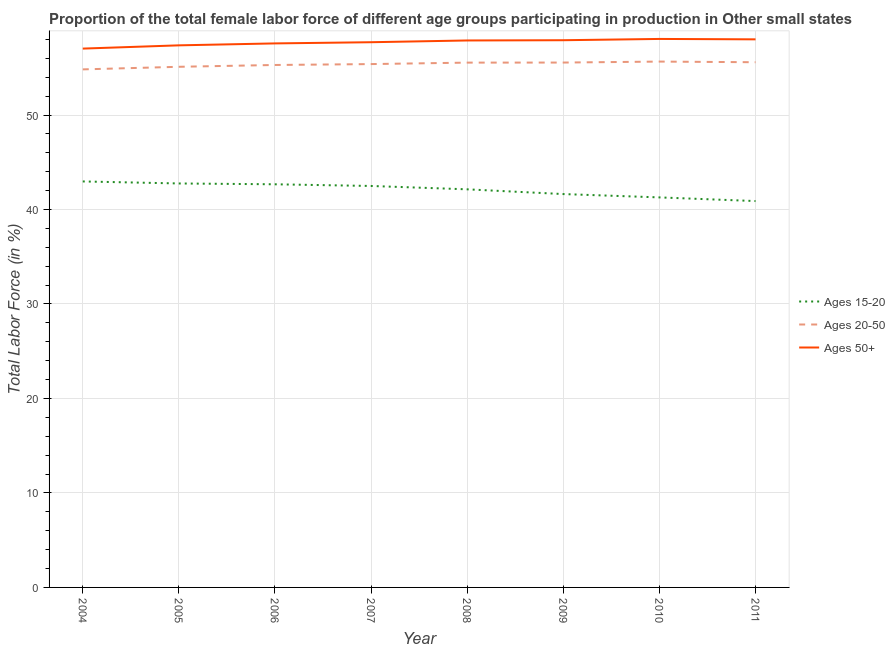How many different coloured lines are there?
Provide a short and direct response. 3. Is the number of lines equal to the number of legend labels?
Offer a very short reply. Yes. What is the percentage of female labor force within the age group 20-50 in 2009?
Your answer should be compact. 55.55. Across all years, what is the maximum percentage of female labor force within the age group 15-20?
Keep it short and to the point. 42.97. Across all years, what is the minimum percentage of female labor force within the age group 20-50?
Your answer should be compact. 54.83. In which year was the percentage of female labor force within the age group 15-20 minimum?
Provide a short and direct response. 2011. What is the total percentage of female labor force within the age group 20-50 in the graph?
Offer a very short reply. 442.95. What is the difference between the percentage of female labor force above age 50 in 2008 and that in 2011?
Offer a terse response. -0.12. What is the difference between the percentage of female labor force within the age group 15-20 in 2007 and the percentage of female labor force within the age group 20-50 in 2005?
Offer a very short reply. -12.61. What is the average percentage of female labor force above age 50 per year?
Your answer should be very brief. 57.69. In the year 2008, what is the difference between the percentage of female labor force within the age group 20-50 and percentage of female labor force within the age group 15-20?
Offer a terse response. 13.41. In how many years, is the percentage of female labor force above age 50 greater than 52 %?
Keep it short and to the point. 8. What is the ratio of the percentage of female labor force above age 50 in 2004 to that in 2008?
Your answer should be compact. 0.99. Is the percentage of female labor force above age 50 in 2009 less than that in 2011?
Ensure brevity in your answer.  Yes. Is the difference between the percentage of female labor force within the age group 15-20 in 2005 and 2008 greater than the difference between the percentage of female labor force within the age group 20-50 in 2005 and 2008?
Offer a very short reply. Yes. What is the difference between the highest and the second highest percentage of female labor force above age 50?
Provide a short and direct response. 0.04. What is the difference between the highest and the lowest percentage of female labor force above age 50?
Ensure brevity in your answer.  1.02. Does the percentage of female labor force within the age group 20-50 monotonically increase over the years?
Offer a terse response. No. How many lines are there?
Provide a succinct answer. 3. How many years are there in the graph?
Provide a succinct answer. 8. What is the difference between two consecutive major ticks on the Y-axis?
Offer a terse response. 10. Where does the legend appear in the graph?
Give a very brief answer. Center right. How are the legend labels stacked?
Your response must be concise. Vertical. What is the title of the graph?
Provide a short and direct response. Proportion of the total female labor force of different age groups participating in production in Other small states. Does "Transport equipments" appear as one of the legend labels in the graph?
Ensure brevity in your answer.  No. What is the Total Labor Force (in %) in Ages 15-20 in 2004?
Give a very brief answer. 42.97. What is the Total Labor Force (in %) in Ages 20-50 in 2004?
Offer a terse response. 54.83. What is the Total Labor Force (in %) of Ages 50+ in 2004?
Provide a short and direct response. 57.03. What is the Total Labor Force (in %) in Ages 15-20 in 2005?
Provide a short and direct response. 42.75. What is the Total Labor Force (in %) in Ages 20-50 in 2005?
Ensure brevity in your answer.  55.1. What is the Total Labor Force (in %) of Ages 50+ in 2005?
Give a very brief answer. 57.37. What is the Total Labor Force (in %) of Ages 15-20 in 2006?
Your answer should be compact. 42.67. What is the Total Labor Force (in %) of Ages 20-50 in 2006?
Give a very brief answer. 55.3. What is the Total Labor Force (in %) of Ages 50+ in 2006?
Offer a terse response. 57.58. What is the Total Labor Force (in %) in Ages 15-20 in 2007?
Your response must be concise. 42.49. What is the Total Labor Force (in %) in Ages 20-50 in 2007?
Offer a terse response. 55.39. What is the Total Labor Force (in %) in Ages 50+ in 2007?
Your answer should be very brief. 57.7. What is the Total Labor Force (in %) in Ages 15-20 in 2008?
Keep it short and to the point. 42.13. What is the Total Labor Force (in %) in Ages 20-50 in 2008?
Keep it short and to the point. 55.54. What is the Total Labor Force (in %) in Ages 50+ in 2008?
Provide a short and direct response. 57.89. What is the Total Labor Force (in %) in Ages 15-20 in 2009?
Make the answer very short. 41.63. What is the Total Labor Force (in %) in Ages 20-50 in 2009?
Your answer should be compact. 55.55. What is the Total Labor Force (in %) in Ages 50+ in 2009?
Your response must be concise. 57.92. What is the Total Labor Force (in %) in Ages 15-20 in 2010?
Provide a short and direct response. 41.28. What is the Total Labor Force (in %) of Ages 20-50 in 2010?
Offer a terse response. 55.65. What is the Total Labor Force (in %) in Ages 50+ in 2010?
Your answer should be very brief. 58.05. What is the Total Labor Force (in %) in Ages 15-20 in 2011?
Your answer should be compact. 40.89. What is the Total Labor Force (in %) of Ages 20-50 in 2011?
Make the answer very short. 55.59. What is the Total Labor Force (in %) in Ages 50+ in 2011?
Provide a short and direct response. 58.01. Across all years, what is the maximum Total Labor Force (in %) in Ages 15-20?
Offer a terse response. 42.97. Across all years, what is the maximum Total Labor Force (in %) of Ages 20-50?
Your answer should be very brief. 55.65. Across all years, what is the maximum Total Labor Force (in %) in Ages 50+?
Give a very brief answer. 58.05. Across all years, what is the minimum Total Labor Force (in %) of Ages 15-20?
Keep it short and to the point. 40.89. Across all years, what is the minimum Total Labor Force (in %) in Ages 20-50?
Give a very brief answer. 54.83. Across all years, what is the minimum Total Labor Force (in %) of Ages 50+?
Offer a very short reply. 57.03. What is the total Total Labor Force (in %) in Ages 15-20 in the graph?
Make the answer very short. 336.82. What is the total Total Labor Force (in %) in Ages 20-50 in the graph?
Your answer should be compact. 442.95. What is the total Total Labor Force (in %) in Ages 50+ in the graph?
Keep it short and to the point. 461.55. What is the difference between the Total Labor Force (in %) in Ages 15-20 in 2004 and that in 2005?
Provide a succinct answer. 0.21. What is the difference between the Total Labor Force (in %) of Ages 20-50 in 2004 and that in 2005?
Your response must be concise. -0.27. What is the difference between the Total Labor Force (in %) in Ages 50+ in 2004 and that in 2005?
Your response must be concise. -0.35. What is the difference between the Total Labor Force (in %) of Ages 15-20 in 2004 and that in 2006?
Give a very brief answer. 0.3. What is the difference between the Total Labor Force (in %) in Ages 20-50 in 2004 and that in 2006?
Your answer should be very brief. -0.47. What is the difference between the Total Labor Force (in %) of Ages 50+ in 2004 and that in 2006?
Ensure brevity in your answer.  -0.55. What is the difference between the Total Labor Force (in %) in Ages 15-20 in 2004 and that in 2007?
Offer a terse response. 0.48. What is the difference between the Total Labor Force (in %) of Ages 20-50 in 2004 and that in 2007?
Keep it short and to the point. -0.56. What is the difference between the Total Labor Force (in %) in Ages 50+ in 2004 and that in 2007?
Give a very brief answer. -0.68. What is the difference between the Total Labor Force (in %) of Ages 15-20 in 2004 and that in 2008?
Your answer should be very brief. 0.84. What is the difference between the Total Labor Force (in %) of Ages 20-50 in 2004 and that in 2008?
Your answer should be compact. -0.72. What is the difference between the Total Labor Force (in %) of Ages 50+ in 2004 and that in 2008?
Keep it short and to the point. -0.86. What is the difference between the Total Labor Force (in %) of Ages 15-20 in 2004 and that in 2009?
Ensure brevity in your answer.  1.34. What is the difference between the Total Labor Force (in %) in Ages 20-50 in 2004 and that in 2009?
Provide a succinct answer. -0.72. What is the difference between the Total Labor Force (in %) of Ages 50+ in 2004 and that in 2009?
Offer a very short reply. -0.89. What is the difference between the Total Labor Force (in %) of Ages 15-20 in 2004 and that in 2010?
Give a very brief answer. 1.69. What is the difference between the Total Labor Force (in %) of Ages 20-50 in 2004 and that in 2010?
Offer a very short reply. -0.83. What is the difference between the Total Labor Force (in %) of Ages 50+ in 2004 and that in 2010?
Give a very brief answer. -1.02. What is the difference between the Total Labor Force (in %) of Ages 15-20 in 2004 and that in 2011?
Offer a very short reply. 2.08. What is the difference between the Total Labor Force (in %) of Ages 20-50 in 2004 and that in 2011?
Keep it short and to the point. -0.76. What is the difference between the Total Labor Force (in %) in Ages 50+ in 2004 and that in 2011?
Your answer should be compact. -0.98. What is the difference between the Total Labor Force (in %) in Ages 15-20 in 2005 and that in 2006?
Your response must be concise. 0.09. What is the difference between the Total Labor Force (in %) in Ages 20-50 in 2005 and that in 2006?
Keep it short and to the point. -0.19. What is the difference between the Total Labor Force (in %) of Ages 50+ in 2005 and that in 2006?
Your answer should be very brief. -0.2. What is the difference between the Total Labor Force (in %) in Ages 15-20 in 2005 and that in 2007?
Your answer should be compact. 0.27. What is the difference between the Total Labor Force (in %) of Ages 20-50 in 2005 and that in 2007?
Make the answer very short. -0.29. What is the difference between the Total Labor Force (in %) of Ages 50+ in 2005 and that in 2007?
Ensure brevity in your answer.  -0.33. What is the difference between the Total Labor Force (in %) of Ages 15-20 in 2005 and that in 2008?
Make the answer very short. 0.62. What is the difference between the Total Labor Force (in %) of Ages 20-50 in 2005 and that in 2008?
Ensure brevity in your answer.  -0.44. What is the difference between the Total Labor Force (in %) of Ages 50+ in 2005 and that in 2008?
Offer a terse response. -0.52. What is the difference between the Total Labor Force (in %) in Ages 15-20 in 2005 and that in 2009?
Keep it short and to the point. 1.12. What is the difference between the Total Labor Force (in %) in Ages 20-50 in 2005 and that in 2009?
Keep it short and to the point. -0.45. What is the difference between the Total Labor Force (in %) of Ages 50+ in 2005 and that in 2009?
Your answer should be compact. -0.54. What is the difference between the Total Labor Force (in %) in Ages 15-20 in 2005 and that in 2010?
Provide a succinct answer. 1.48. What is the difference between the Total Labor Force (in %) in Ages 20-50 in 2005 and that in 2010?
Ensure brevity in your answer.  -0.55. What is the difference between the Total Labor Force (in %) in Ages 50+ in 2005 and that in 2010?
Make the answer very short. -0.68. What is the difference between the Total Labor Force (in %) of Ages 15-20 in 2005 and that in 2011?
Your response must be concise. 1.86. What is the difference between the Total Labor Force (in %) of Ages 20-50 in 2005 and that in 2011?
Provide a succinct answer. -0.48. What is the difference between the Total Labor Force (in %) of Ages 50+ in 2005 and that in 2011?
Your answer should be compact. -0.63. What is the difference between the Total Labor Force (in %) in Ages 15-20 in 2006 and that in 2007?
Give a very brief answer. 0.18. What is the difference between the Total Labor Force (in %) in Ages 20-50 in 2006 and that in 2007?
Your answer should be compact. -0.09. What is the difference between the Total Labor Force (in %) of Ages 50+ in 2006 and that in 2007?
Offer a very short reply. -0.13. What is the difference between the Total Labor Force (in %) of Ages 15-20 in 2006 and that in 2008?
Offer a very short reply. 0.53. What is the difference between the Total Labor Force (in %) in Ages 20-50 in 2006 and that in 2008?
Offer a terse response. -0.25. What is the difference between the Total Labor Force (in %) of Ages 50+ in 2006 and that in 2008?
Provide a short and direct response. -0.31. What is the difference between the Total Labor Force (in %) in Ages 15-20 in 2006 and that in 2009?
Your answer should be compact. 1.03. What is the difference between the Total Labor Force (in %) of Ages 20-50 in 2006 and that in 2009?
Your response must be concise. -0.26. What is the difference between the Total Labor Force (in %) in Ages 50+ in 2006 and that in 2009?
Your answer should be very brief. -0.34. What is the difference between the Total Labor Force (in %) of Ages 15-20 in 2006 and that in 2010?
Your answer should be very brief. 1.39. What is the difference between the Total Labor Force (in %) of Ages 20-50 in 2006 and that in 2010?
Your response must be concise. -0.36. What is the difference between the Total Labor Force (in %) in Ages 50+ in 2006 and that in 2010?
Your response must be concise. -0.47. What is the difference between the Total Labor Force (in %) of Ages 15-20 in 2006 and that in 2011?
Your answer should be very brief. 1.78. What is the difference between the Total Labor Force (in %) in Ages 20-50 in 2006 and that in 2011?
Provide a succinct answer. -0.29. What is the difference between the Total Labor Force (in %) in Ages 50+ in 2006 and that in 2011?
Your answer should be very brief. -0.43. What is the difference between the Total Labor Force (in %) in Ages 15-20 in 2007 and that in 2008?
Offer a terse response. 0.35. What is the difference between the Total Labor Force (in %) of Ages 20-50 in 2007 and that in 2008?
Ensure brevity in your answer.  -0.15. What is the difference between the Total Labor Force (in %) in Ages 50+ in 2007 and that in 2008?
Give a very brief answer. -0.18. What is the difference between the Total Labor Force (in %) in Ages 15-20 in 2007 and that in 2009?
Your response must be concise. 0.86. What is the difference between the Total Labor Force (in %) in Ages 20-50 in 2007 and that in 2009?
Provide a succinct answer. -0.16. What is the difference between the Total Labor Force (in %) of Ages 50+ in 2007 and that in 2009?
Make the answer very short. -0.21. What is the difference between the Total Labor Force (in %) of Ages 15-20 in 2007 and that in 2010?
Offer a terse response. 1.21. What is the difference between the Total Labor Force (in %) in Ages 20-50 in 2007 and that in 2010?
Provide a succinct answer. -0.26. What is the difference between the Total Labor Force (in %) in Ages 50+ in 2007 and that in 2010?
Ensure brevity in your answer.  -0.35. What is the difference between the Total Labor Force (in %) in Ages 15-20 in 2007 and that in 2011?
Your answer should be very brief. 1.6. What is the difference between the Total Labor Force (in %) in Ages 20-50 in 2007 and that in 2011?
Provide a succinct answer. -0.2. What is the difference between the Total Labor Force (in %) of Ages 50+ in 2007 and that in 2011?
Offer a terse response. -0.3. What is the difference between the Total Labor Force (in %) in Ages 15-20 in 2008 and that in 2009?
Your answer should be very brief. 0.5. What is the difference between the Total Labor Force (in %) of Ages 20-50 in 2008 and that in 2009?
Offer a terse response. -0.01. What is the difference between the Total Labor Force (in %) of Ages 50+ in 2008 and that in 2009?
Give a very brief answer. -0.03. What is the difference between the Total Labor Force (in %) in Ages 15-20 in 2008 and that in 2010?
Your answer should be compact. 0.85. What is the difference between the Total Labor Force (in %) in Ages 20-50 in 2008 and that in 2010?
Your response must be concise. -0.11. What is the difference between the Total Labor Force (in %) in Ages 50+ in 2008 and that in 2010?
Provide a succinct answer. -0.16. What is the difference between the Total Labor Force (in %) of Ages 15-20 in 2008 and that in 2011?
Provide a short and direct response. 1.24. What is the difference between the Total Labor Force (in %) of Ages 20-50 in 2008 and that in 2011?
Provide a short and direct response. -0.04. What is the difference between the Total Labor Force (in %) in Ages 50+ in 2008 and that in 2011?
Offer a very short reply. -0.12. What is the difference between the Total Labor Force (in %) in Ages 15-20 in 2009 and that in 2010?
Keep it short and to the point. 0.35. What is the difference between the Total Labor Force (in %) in Ages 20-50 in 2009 and that in 2010?
Give a very brief answer. -0.1. What is the difference between the Total Labor Force (in %) of Ages 50+ in 2009 and that in 2010?
Ensure brevity in your answer.  -0.14. What is the difference between the Total Labor Force (in %) of Ages 15-20 in 2009 and that in 2011?
Your response must be concise. 0.74. What is the difference between the Total Labor Force (in %) of Ages 20-50 in 2009 and that in 2011?
Provide a succinct answer. -0.03. What is the difference between the Total Labor Force (in %) of Ages 50+ in 2009 and that in 2011?
Provide a short and direct response. -0.09. What is the difference between the Total Labor Force (in %) in Ages 15-20 in 2010 and that in 2011?
Give a very brief answer. 0.39. What is the difference between the Total Labor Force (in %) of Ages 20-50 in 2010 and that in 2011?
Your answer should be compact. 0.07. What is the difference between the Total Labor Force (in %) in Ages 50+ in 2010 and that in 2011?
Provide a succinct answer. 0.04. What is the difference between the Total Labor Force (in %) of Ages 15-20 in 2004 and the Total Labor Force (in %) of Ages 20-50 in 2005?
Your answer should be compact. -12.13. What is the difference between the Total Labor Force (in %) of Ages 15-20 in 2004 and the Total Labor Force (in %) of Ages 50+ in 2005?
Your answer should be very brief. -14.4. What is the difference between the Total Labor Force (in %) in Ages 20-50 in 2004 and the Total Labor Force (in %) in Ages 50+ in 2005?
Your answer should be compact. -2.54. What is the difference between the Total Labor Force (in %) in Ages 15-20 in 2004 and the Total Labor Force (in %) in Ages 20-50 in 2006?
Give a very brief answer. -12.33. What is the difference between the Total Labor Force (in %) of Ages 15-20 in 2004 and the Total Labor Force (in %) of Ages 50+ in 2006?
Provide a short and direct response. -14.61. What is the difference between the Total Labor Force (in %) of Ages 20-50 in 2004 and the Total Labor Force (in %) of Ages 50+ in 2006?
Offer a very short reply. -2.75. What is the difference between the Total Labor Force (in %) of Ages 15-20 in 2004 and the Total Labor Force (in %) of Ages 20-50 in 2007?
Ensure brevity in your answer.  -12.42. What is the difference between the Total Labor Force (in %) in Ages 15-20 in 2004 and the Total Labor Force (in %) in Ages 50+ in 2007?
Your answer should be compact. -14.74. What is the difference between the Total Labor Force (in %) in Ages 20-50 in 2004 and the Total Labor Force (in %) in Ages 50+ in 2007?
Provide a succinct answer. -2.88. What is the difference between the Total Labor Force (in %) in Ages 15-20 in 2004 and the Total Labor Force (in %) in Ages 20-50 in 2008?
Provide a succinct answer. -12.58. What is the difference between the Total Labor Force (in %) of Ages 15-20 in 2004 and the Total Labor Force (in %) of Ages 50+ in 2008?
Provide a short and direct response. -14.92. What is the difference between the Total Labor Force (in %) of Ages 20-50 in 2004 and the Total Labor Force (in %) of Ages 50+ in 2008?
Provide a short and direct response. -3.06. What is the difference between the Total Labor Force (in %) of Ages 15-20 in 2004 and the Total Labor Force (in %) of Ages 20-50 in 2009?
Keep it short and to the point. -12.58. What is the difference between the Total Labor Force (in %) in Ages 15-20 in 2004 and the Total Labor Force (in %) in Ages 50+ in 2009?
Ensure brevity in your answer.  -14.95. What is the difference between the Total Labor Force (in %) in Ages 20-50 in 2004 and the Total Labor Force (in %) in Ages 50+ in 2009?
Give a very brief answer. -3.09. What is the difference between the Total Labor Force (in %) of Ages 15-20 in 2004 and the Total Labor Force (in %) of Ages 20-50 in 2010?
Provide a short and direct response. -12.69. What is the difference between the Total Labor Force (in %) of Ages 15-20 in 2004 and the Total Labor Force (in %) of Ages 50+ in 2010?
Your response must be concise. -15.08. What is the difference between the Total Labor Force (in %) of Ages 20-50 in 2004 and the Total Labor Force (in %) of Ages 50+ in 2010?
Your answer should be very brief. -3.22. What is the difference between the Total Labor Force (in %) of Ages 15-20 in 2004 and the Total Labor Force (in %) of Ages 20-50 in 2011?
Make the answer very short. -12.62. What is the difference between the Total Labor Force (in %) of Ages 15-20 in 2004 and the Total Labor Force (in %) of Ages 50+ in 2011?
Provide a short and direct response. -15.04. What is the difference between the Total Labor Force (in %) in Ages 20-50 in 2004 and the Total Labor Force (in %) in Ages 50+ in 2011?
Provide a short and direct response. -3.18. What is the difference between the Total Labor Force (in %) of Ages 15-20 in 2005 and the Total Labor Force (in %) of Ages 20-50 in 2006?
Keep it short and to the point. -12.54. What is the difference between the Total Labor Force (in %) of Ages 15-20 in 2005 and the Total Labor Force (in %) of Ages 50+ in 2006?
Your response must be concise. -14.82. What is the difference between the Total Labor Force (in %) in Ages 20-50 in 2005 and the Total Labor Force (in %) in Ages 50+ in 2006?
Provide a short and direct response. -2.48. What is the difference between the Total Labor Force (in %) in Ages 15-20 in 2005 and the Total Labor Force (in %) in Ages 20-50 in 2007?
Make the answer very short. -12.64. What is the difference between the Total Labor Force (in %) in Ages 15-20 in 2005 and the Total Labor Force (in %) in Ages 50+ in 2007?
Ensure brevity in your answer.  -14.95. What is the difference between the Total Labor Force (in %) of Ages 20-50 in 2005 and the Total Labor Force (in %) of Ages 50+ in 2007?
Offer a very short reply. -2.6. What is the difference between the Total Labor Force (in %) of Ages 15-20 in 2005 and the Total Labor Force (in %) of Ages 20-50 in 2008?
Your answer should be compact. -12.79. What is the difference between the Total Labor Force (in %) in Ages 15-20 in 2005 and the Total Labor Force (in %) in Ages 50+ in 2008?
Make the answer very short. -15.13. What is the difference between the Total Labor Force (in %) in Ages 20-50 in 2005 and the Total Labor Force (in %) in Ages 50+ in 2008?
Provide a short and direct response. -2.79. What is the difference between the Total Labor Force (in %) in Ages 15-20 in 2005 and the Total Labor Force (in %) in Ages 20-50 in 2009?
Your response must be concise. -12.8. What is the difference between the Total Labor Force (in %) of Ages 15-20 in 2005 and the Total Labor Force (in %) of Ages 50+ in 2009?
Your response must be concise. -15.16. What is the difference between the Total Labor Force (in %) in Ages 20-50 in 2005 and the Total Labor Force (in %) in Ages 50+ in 2009?
Provide a succinct answer. -2.81. What is the difference between the Total Labor Force (in %) of Ages 15-20 in 2005 and the Total Labor Force (in %) of Ages 20-50 in 2010?
Give a very brief answer. -12.9. What is the difference between the Total Labor Force (in %) in Ages 15-20 in 2005 and the Total Labor Force (in %) in Ages 50+ in 2010?
Offer a terse response. -15.3. What is the difference between the Total Labor Force (in %) in Ages 20-50 in 2005 and the Total Labor Force (in %) in Ages 50+ in 2010?
Give a very brief answer. -2.95. What is the difference between the Total Labor Force (in %) in Ages 15-20 in 2005 and the Total Labor Force (in %) in Ages 20-50 in 2011?
Your answer should be compact. -12.83. What is the difference between the Total Labor Force (in %) in Ages 15-20 in 2005 and the Total Labor Force (in %) in Ages 50+ in 2011?
Ensure brevity in your answer.  -15.25. What is the difference between the Total Labor Force (in %) in Ages 20-50 in 2005 and the Total Labor Force (in %) in Ages 50+ in 2011?
Your response must be concise. -2.91. What is the difference between the Total Labor Force (in %) in Ages 15-20 in 2006 and the Total Labor Force (in %) in Ages 20-50 in 2007?
Ensure brevity in your answer.  -12.72. What is the difference between the Total Labor Force (in %) of Ages 15-20 in 2006 and the Total Labor Force (in %) of Ages 50+ in 2007?
Provide a succinct answer. -15.04. What is the difference between the Total Labor Force (in %) of Ages 20-50 in 2006 and the Total Labor Force (in %) of Ages 50+ in 2007?
Provide a short and direct response. -2.41. What is the difference between the Total Labor Force (in %) of Ages 15-20 in 2006 and the Total Labor Force (in %) of Ages 20-50 in 2008?
Give a very brief answer. -12.88. What is the difference between the Total Labor Force (in %) in Ages 15-20 in 2006 and the Total Labor Force (in %) in Ages 50+ in 2008?
Provide a succinct answer. -15.22. What is the difference between the Total Labor Force (in %) of Ages 20-50 in 2006 and the Total Labor Force (in %) of Ages 50+ in 2008?
Give a very brief answer. -2.59. What is the difference between the Total Labor Force (in %) in Ages 15-20 in 2006 and the Total Labor Force (in %) in Ages 20-50 in 2009?
Provide a succinct answer. -12.88. What is the difference between the Total Labor Force (in %) of Ages 15-20 in 2006 and the Total Labor Force (in %) of Ages 50+ in 2009?
Provide a succinct answer. -15.25. What is the difference between the Total Labor Force (in %) in Ages 20-50 in 2006 and the Total Labor Force (in %) in Ages 50+ in 2009?
Your answer should be compact. -2.62. What is the difference between the Total Labor Force (in %) in Ages 15-20 in 2006 and the Total Labor Force (in %) in Ages 20-50 in 2010?
Provide a succinct answer. -12.99. What is the difference between the Total Labor Force (in %) in Ages 15-20 in 2006 and the Total Labor Force (in %) in Ages 50+ in 2010?
Offer a very short reply. -15.38. What is the difference between the Total Labor Force (in %) in Ages 20-50 in 2006 and the Total Labor Force (in %) in Ages 50+ in 2010?
Ensure brevity in your answer.  -2.76. What is the difference between the Total Labor Force (in %) in Ages 15-20 in 2006 and the Total Labor Force (in %) in Ages 20-50 in 2011?
Ensure brevity in your answer.  -12.92. What is the difference between the Total Labor Force (in %) of Ages 15-20 in 2006 and the Total Labor Force (in %) of Ages 50+ in 2011?
Offer a very short reply. -15.34. What is the difference between the Total Labor Force (in %) in Ages 20-50 in 2006 and the Total Labor Force (in %) in Ages 50+ in 2011?
Provide a short and direct response. -2.71. What is the difference between the Total Labor Force (in %) in Ages 15-20 in 2007 and the Total Labor Force (in %) in Ages 20-50 in 2008?
Ensure brevity in your answer.  -13.06. What is the difference between the Total Labor Force (in %) of Ages 15-20 in 2007 and the Total Labor Force (in %) of Ages 50+ in 2008?
Offer a terse response. -15.4. What is the difference between the Total Labor Force (in %) of Ages 20-50 in 2007 and the Total Labor Force (in %) of Ages 50+ in 2008?
Provide a short and direct response. -2.5. What is the difference between the Total Labor Force (in %) of Ages 15-20 in 2007 and the Total Labor Force (in %) of Ages 20-50 in 2009?
Your answer should be very brief. -13.06. What is the difference between the Total Labor Force (in %) in Ages 15-20 in 2007 and the Total Labor Force (in %) in Ages 50+ in 2009?
Provide a short and direct response. -15.43. What is the difference between the Total Labor Force (in %) of Ages 20-50 in 2007 and the Total Labor Force (in %) of Ages 50+ in 2009?
Give a very brief answer. -2.53. What is the difference between the Total Labor Force (in %) in Ages 15-20 in 2007 and the Total Labor Force (in %) in Ages 20-50 in 2010?
Keep it short and to the point. -13.17. What is the difference between the Total Labor Force (in %) of Ages 15-20 in 2007 and the Total Labor Force (in %) of Ages 50+ in 2010?
Provide a succinct answer. -15.56. What is the difference between the Total Labor Force (in %) in Ages 20-50 in 2007 and the Total Labor Force (in %) in Ages 50+ in 2010?
Offer a terse response. -2.66. What is the difference between the Total Labor Force (in %) in Ages 15-20 in 2007 and the Total Labor Force (in %) in Ages 20-50 in 2011?
Offer a terse response. -13.1. What is the difference between the Total Labor Force (in %) of Ages 15-20 in 2007 and the Total Labor Force (in %) of Ages 50+ in 2011?
Provide a succinct answer. -15.52. What is the difference between the Total Labor Force (in %) in Ages 20-50 in 2007 and the Total Labor Force (in %) in Ages 50+ in 2011?
Provide a succinct answer. -2.62. What is the difference between the Total Labor Force (in %) in Ages 15-20 in 2008 and the Total Labor Force (in %) in Ages 20-50 in 2009?
Provide a succinct answer. -13.42. What is the difference between the Total Labor Force (in %) of Ages 15-20 in 2008 and the Total Labor Force (in %) of Ages 50+ in 2009?
Give a very brief answer. -15.78. What is the difference between the Total Labor Force (in %) of Ages 20-50 in 2008 and the Total Labor Force (in %) of Ages 50+ in 2009?
Keep it short and to the point. -2.37. What is the difference between the Total Labor Force (in %) of Ages 15-20 in 2008 and the Total Labor Force (in %) of Ages 20-50 in 2010?
Offer a very short reply. -13.52. What is the difference between the Total Labor Force (in %) in Ages 15-20 in 2008 and the Total Labor Force (in %) in Ages 50+ in 2010?
Offer a very short reply. -15.92. What is the difference between the Total Labor Force (in %) in Ages 20-50 in 2008 and the Total Labor Force (in %) in Ages 50+ in 2010?
Offer a terse response. -2.51. What is the difference between the Total Labor Force (in %) in Ages 15-20 in 2008 and the Total Labor Force (in %) in Ages 20-50 in 2011?
Your response must be concise. -13.45. What is the difference between the Total Labor Force (in %) in Ages 15-20 in 2008 and the Total Labor Force (in %) in Ages 50+ in 2011?
Provide a succinct answer. -15.87. What is the difference between the Total Labor Force (in %) of Ages 20-50 in 2008 and the Total Labor Force (in %) of Ages 50+ in 2011?
Make the answer very short. -2.46. What is the difference between the Total Labor Force (in %) of Ages 15-20 in 2009 and the Total Labor Force (in %) of Ages 20-50 in 2010?
Provide a succinct answer. -14.02. What is the difference between the Total Labor Force (in %) of Ages 15-20 in 2009 and the Total Labor Force (in %) of Ages 50+ in 2010?
Offer a very short reply. -16.42. What is the difference between the Total Labor Force (in %) in Ages 15-20 in 2009 and the Total Labor Force (in %) in Ages 20-50 in 2011?
Provide a succinct answer. -13.95. What is the difference between the Total Labor Force (in %) of Ages 15-20 in 2009 and the Total Labor Force (in %) of Ages 50+ in 2011?
Provide a succinct answer. -16.38. What is the difference between the Total Labor Force (in %) in Ages 20-50 in 2009 and the Total Labor Force (in %) in Ages 50+ in 2011?
Provide a short and direct response. -2.46. What is the difference between the Total Labor Force (in %) in Ages 15-20 in 2010 and the Total Labor Force (in %) in Ages 20-50 in 2011?
Your answer should be very brief. -14.31. What is the difference between the Total Labor Force (in %) in Ages 15-20 in 2010 and the Total Labor Force (in %) in Ages 50+ in 2011?
Your answer should be very brief. -16.73. What is the difference between the Total Labor Force (in %) of Ages 20-50 in 2010 and the Total Labor Force (in %) of Ages 50+ in 2011?
Provide a short and direct response. -2.35. What is the average Total Labor Force (in %) of Ages 15-20 per year?
Offer a terse response. 42.1. What is the average Total Labor Force (in %) in Ages 20-50 per year?
Make the answer very short. 55.37. What is the average Total Labor Force (in %) of Ages 50+ per year?
Provide a short and direct response. 57.69. In the year 2004, what is the difference between the Total Labor Force (in %) in Ages 15-20 and Total Labor Force (in %) in Ages 20-50?
Provide a short and direct response. -11.86. In the year 2004, what is the difference between the Total Labor Force (in %) in Ages 15-20 and Total Labor Force (in %) in Ages 50+?
Keep it short and to the point. -14.06. In the year 2004, what is the difference between the Total Labor Force (in %) of Ages 20-50 and Total Labor Force (in %) of Ages 50+?
Your response must be concise. -2.2. In the year 2005, what is the difference between the Total Labor Force (in %) in Ages 15-20 and Total Labor Force (in %) in Ages 20-50?
Ensure brevity in your answer.  -12.35. In the year 2005, what is the difference between the Total Labor Force (in %) of Ages 15-20 and Total Labor Force (in %) of Ages 50+?
Ensure brevity in your answer.  -14.62. In the year 2005, what is the difference between the Total Labor Force (in %) of Ages 20-50 and Total Labor Force (in %) of Ages 50+?
Provide a succinct answer. -2.27. In the year 2006, what is the difference between the Total Labor Force (in %) in Ages 15-20 and Total Labor Force (in %) in Ages 20-50?
Give a very brief answer. -12.63. In the year 2006, what is the difference between the Total Labor Force (in %) of Ages 15-20 and Total Labor Force (in %) of Ages 50+?
Provide a short and direct response. -14.91. In the year 2006, what is the difference between the Total Labor Force (in %) in Ages 20-50 and Total Labor Force (in %) in Ages 50+?
Offer a terse response. -2.28. In the year 2007, what is the difference between the Total Labor Force (in %) of Ages 15-20 and Total Labor Force (in %) of Ages 20-50?
Provide a short and direct response. -12.9. In the year 2007, what is the difference between the Total Labor Force (in %) of Ages 15-20 and Total Labor Force (in %) of Ages 50+?
Your response must be concise. -15.22. In the year 2007, what is the difference between the Total Labor Force (in %) of Ages 20-50 and Total Labor Force (in %) of Ages 50+?
Make the answer very short. -2.31. In the year 2008, what is the difference between the Total Labor Force (in %) of Ages 15-20 and Total Labor Force (in %) of Ages 20-50?
Provide a short and direct response. -13.41. In the year 2008, what is the difference between the Total Labor Force (in %) in Ages 15-20 and Total Labor Force (in %) in Ages 50+?
Make the answer very short. -15.75. In the year 2008, what is the difference between the Total Labor Force (in %) in Ages 20-50 and Total Labor Force (in %) in Ages 50+?
Your answer should be very brief. -2.34. In the year 2009, what is the difference between the Total Labor Force (in %) of Ages 15-20 and Total Labor Force (in %) of Ages 20-50?
Your answer should be compact. -13.92. In the year 2009, what is the difference between the Total Labor Force (in %) in Ages 15-20 and Total Labor Force (in %) in Ages 50+?
Your answer should be compact. -16.28. In the year 2009, what is the difference between the Total Labor Force (in %) in Ages 20-50 and Total Labor Force (in %) in Ages 50+?
Your response must be concise. -2.36. In the year 2010, what is the difference between the Total Labor Force (in %) of Ages 15-20 and Total Labor Force (in %) of Ages 20-50?
Make the answer very short. -14.38. In the year 2010, what is the difference between the Total Labor Force (in %) of Ages 15-20 and Total Labor Force (in %) of Ages 50+?
Offer a very short reply. -16.77. In the year 2010, what is the difference between the Total Labor Force (in %) of Ages 20-50 and Total Labor Force (in %) of Ages 50+?
Your answer should be very brief. -2.4. In the year 2011, what is the difference between the Total Labor Force (in %) of Ages 15-20 and Total Labor Force (in %) of Ages 20-50?
Give a very brief answer. -14.69. In the year 2011, what is the difference between the Total Labor Force (in %) of Ages 15-20 and Total Labor Force (in %) of Ages 50+?
Keep it short and to the point. -17.12. In the year 2011, what is the difference between the Total Labor Force (in %) in Ages 20-50 and Total Labor Force (in %) in Ages 50+?
Ensure brevity in your answer.  -2.42. What is the ratio of the Total Labor Force (in %) in Ages 15-20 in 2004 to that in 2005?
Offer a very short reply. 1. What is the ratio of the Total Labor Force (in %) in Ages 20-50 in 2004 to that in 2005?
Your answer should be very brief. 0.99. What is the ratio of the Total Labor Force (in %) of Ages 15-20 in 2004 to that in 2006?
Your answer should be very brief. 1.01. What is the ratio of the Total Labor Force (in %) of Ages 20-50 in 2004 to that in 2006?
Give a very brief answer. 0.99. What is the ratio of the Total Labor Force (in %) of Ages 50+ in 2004 to that in 2006?
Offer a very short reply. 0.99. What is the ratio of the Total Labor Force (in %) of Ages 15-20 in 2004 to that in 2007?
Keep it short and to the point. 1.01. What is the ratio of the Total Labor Force (in %) of Ages 20-50 in 2004 to that in 2007?
Make the answer very short. 0.99. What is the ratio of the Total Labor Force (in %) of Ages 50+ in 2004 to that in 2007?
Your answer should be very brief. 0.99. What is the ratio of the Total Labor Force (in %) in Ages 15-20 in 2004 to that in 2008?
Provide a short and direct response. 1.02. What is the ratio of the Total Labor Force (in %) in Ages 20-50 in 2004 to that in 2008?
Your response must be concise. 0.99. What is the ratio of the Total Labor Force (in %) in Ages 50+ in 2004 to that in 2008?
Keep it short and to the point. 0.99. What is the ratio of the Total Labor Force (in %) of Ages 15-20 in 2004 to that in 2009?
Provide a succinct answer. 1.03. What is the ratio of the Total Labor Force (in %) of Ages 20-50 in 2004 to that in 2009?
Give a very brief answer. 0.99. What is the ratio of the Total Labor Force (in %) of Ages 50+ in 2004 to that in 2009?
Make the answer very short. 0.98. What is the ratio of the Total Labor Force (in %) in Ages 15-20 in 2004 to that in 2010?
Your response must be concise. 1.04. What is the ratio of the Total Labor Force (in %) in Ages 20-50 in 2004 to that in 2010?
Ensure brevity in your answer.  0.99. What is the ratio of the Total Labor Force (in %) of Ages 50+ in 2004 to that in 2010?
Keep it short and to the point. 0.98. What is the ratio of the Total Labor Force (in %) in Ages 15-20 in 2004 to that in 2011?
Offer a very short reply. 1.05. What is the ratio of the Total Labor Force (in %) in Ages 20-50 in 2004 to that in 2011?
Provide a succinct answer. 0.99. What is the ratio of the Total Labor Force (in %) in Ages 50+ in 2004 to that in 2011?
Ensure brevity in your answer.  0.98. What is the ratio of the Total Labor Force (in %) in Ages 20-50 in 2005 to that in 2006?
Offer a terse response. 1. What is the ratio of the Total Labor Force (in %) in Ages 15-20 in 2005 to that in 2008?
Give a very brief answer. 1.01. What is the ratio of the Total Labor Force (in %) of Ages 15-20 in 2005 to that in 2009?
Your answer should be very brief. 1.03. What is the ratio of the Total Labor Force (in %) of Ages 50+ in 2005 to that in 2009?
Your answer should be compact. 0.99. What is the ratio of the Total Labor Force (in %) of Ages 15-20 in 2005 to that in 2010?
Give a very brief answer. 1.04. What is the ratio of the Total Labor Force (in %) of Ages 20-50 in 2005 to that in 2010?
Your answer should be very brief. 0.99. What is the ratio of the Total Labor Force (in %) in Ages 50+ in 2005 to that in 2010?
Provide a short and direct response. 0.99. What is the ratio of the Total Labor Force (in %) of Ages 15-20 in 2005 to that in 2011?
Ensure brevity in your answer.  1.05. What is the ratio of the Total Labor Force (in %) of Ages 50+ in 2005 to that in 2011?
Make the answer very short. 0.99. What is the ratio of the Total Labor Force (in %) of Ages 15-20 in 2006 to that in 2007?
Offer a very short reply. 1. What is the ratio of the Total Labor Force (in %) in Ages 20-50 in 2006 to that in 2007?
Give a very brief answer. 1. What is the ratio of the Total Labor Force (in %) of Ages 15-20 in 2006 to that in 2008?
Ensure brevity in your answer.  1.01. What is the ratio of the Total Labor Force (in %) in Ages 20-50 in 2006 to that in 2008?
Ensure brevity in your answer.  1. What is the ratio of the Total Labor Force (in %) in Ages 50+ in 2006 to that in 2008?
Provide a short and direct response. 0.99. What is the ratio of the Total Labor Force (in %) of Ages 15-20 in 2006 to that in 2009?
Offer a very short reply. 1.02. What is the ratio of the Total Labor Force (in %) in Ages 15-20 in 2006 to that in 2010?
Give a very brief answer. 1.03. What is the ratio of the Total Labor Force (in %) in Ages 15-20 in 2006 to that in 2011?
Offer a very short reply. 1.04. What is the ratio of the Total Labor Force (in %) of Ages 20-50 in 2006 to that in 2011?
Keep it short and to the point. 0.99. What is the ratio of the Total Labor Force (in %) in Ages 15-20 in 2007 to that in 2008?
Make the answer very short. 1.01. What is the ratio of the Total Labor Force (in %) in Ages 20-50 in 2007 to that in 2008?
Your answer should be very brief. 1. What is the ratio of the Total Labor Force (in %) in Ages 15-20 in 2007 to that in 2009?
Your answer should be compact. 1.02. What is the ratio of the Total Labor Force (in %) of Ages 20-50 in 2007 to that in 2009?
Provide a succinct answer. 1. What is the ratio of the Total Labor Force (in %) in Ages 50+ in 2007 to that in 2009?
Keep it short and to the point. 1. What is the ratio of the Total Labor Force (in %) in Ages 15-20 in 2007 to that in 2010?
Your response must be concise. 1.03. What is the ratio of the Total Labor Force (in %) of Ages 50+ in 2007 to that in 2010?
Offer a terse response. 0.99. What is the ratio of the Total Labor Force (in %) of Ages 15-20 in 2007 to that in 2011?
Offer a very short reply. 1.04. What is the ratio of the Total Labor Force (in %) in Ages 50+ in 2007 to that in 2011?
Your response must be concise. 0.99. What is the ratio of the Total Labor Force (in %) in Ages 15-20 in 2008 to that in 2009?
Your response must be concise. 1.01. What is the ratio of the Total Labor Force (in %) in Ages 20-50 in 2008 to that in 2009?
Your answer should be compact. 1. What is the ratio of the Total Labor Force (in %) in Ages 15-20 in 2008 to that in 2010?
Offer a terse response. 1.02. What is the ratio of the Total Labor Force (in %) in Ages 50+ in 2008 to that in 2010?
Keep it short and to the point. 1. What is the ratio of the Total Labor Force (in %) of Ages 15-20 in 2008 to that in 2011?
Offer a very short reply. 1.03. What is the ratio of the Total Labor Force (in %) in Ages 20-50 in 2008 to that in 2011?
Your response must be concise. 1. What is the ratio of the Total Labor Force (in %) of Ages 15-20 in 2009 to that in 2010?
Keep it short and to the point. 1.01. What is the ratio of the Total Labor Force (in %) in Ages 50+ in 2009 to that in 2010?
Your answer should be compact. 1. What is the ratio of the Total Labor Force (in %) in Ages 15-20 in 2009 to that in 2011?
Offer a very short reply. 1.02. What is the ratio of the Total Labor Force (in %) of Ages 20-50 in 2009 to that in 2011?
Give a very brief answer. 1. What is the ratio of the Total Labor Force (in %) in Ages 50+ in 2009 to that in 2011?
Give a very brief answer. 1. What is the ratio of the Total Labor Force (in %) of Ages 15-20 in 2010 to that in 2011?
Provide a succinct answer. 1.01. What is the difference between the highest and the second highest Total Labor Force (in %) of Ages 15-20?
Ensure brevity in your answer.  0.21. What is the difference between the highest and the second highest Total Labor Force (in %) in Ages 20-50?
Give a very brief answer. 0.07. What is the difference between the highest and the second highest Total Labor Force (in %) in Ages 50+?
Ensure brevity in your answer.  0.04. What is the difference between the highest and the lowest Total Labor Force (in %) of Ages 15-20?
Give a very brief answer. 2.08. What is the difference between the highest and the lowest Total Labor Force (in %) in Ages 20-50?
Offer a very short reply. 0.83. What is the difference between the highest and the lowest Total Labor Force (in %) of Ages 50+?
Make the answer very short. 1.02. 